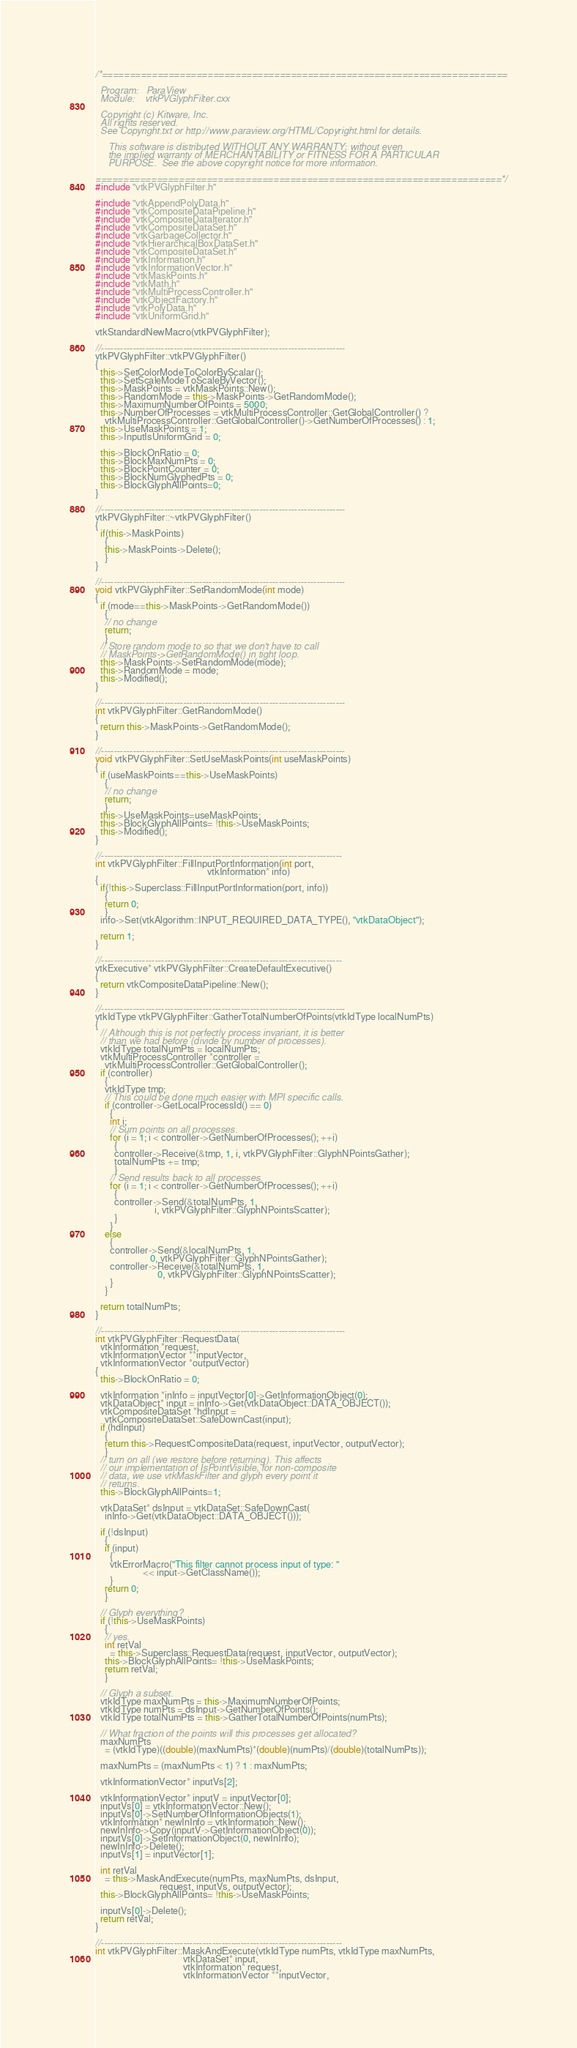Convert code to text. <code><loc_0><loc_0><loc_500><loc_500><_C++_>/*=========================================================================

  Program:   ParaView
  Module:    vtkPVGlyphFilter.cxx

  Copyright (c) Kitware, Inc.
  All rights reserved.
  See Copyright.txt or http://www.paraview.org/HTML/Copyright.html for details.

     This software is distributed WITHOUT ANY WARRANTY; without even
     the implied warranty of MERCHANTABILITY or FITNESS FOR A PARTICULAR
     PURPOSE.  See the above copyright notice for more information.

=========================================================================*/
#include "vtkPVGlyphFilter.h"

#include "vtkAppendPolyData.h"
#include "vtkCompositeDataPipeline.h"
#include "vtkCompositeDataIterator.h"
#include "vtkCompositeDataSet.h"
#include "vtkGarbageCollector.h"
#include "vtkHierarchicalBoxDataSet.h"
#include "vtkCompositeDataSet.h"
#include "vtkInformation.h"
#include "vtkInformationVector.h"
#include "vtkMaskPoints.h"
#include "vtkMath.h"
#include "vtkMultiProcessController.h"
#include "vtkObjectFactory.h"
#include "vtkPolyData.h"
#include "vtkUniformGrid.h"

vtkStandardNewMacro(vtkPVGlyphFilter);

//-----------------------------------------------------------------------------
vtkPVGlyphFilter::vtkPVGlyphFilter()
{
  this->SetColorModeToColorByScalar();
  this->SetScaleModeToScaleByVector();
  this->MaskPoints = vtkMaskPoints::New();
  this->RandomMode = this->MaskPoints->GetRandomMode();
  this->MaximumNumberOfPoints = 5000;
  this->NumberOfProcesses = vtkMultiProcessController::GetGlobalController() ?
    vtkMultiProcessController::GetGlobalController()->GetNumberOfProcesses() : 1;
  this->UseMaskPoints = 1;
  this->InputIsUniformGrid = 0;

  this->BlockOnRatio = 0;
  this->BlockMaxNumPts = 0;
  this->BlockPointCounter = 0;
  this->BlockNumGlyphedPts = 0;
  this->BlockGlyphAllPoints=0;
}

//-----------------------------------------------------------------------------
vtkPVGlyphFilter::~vtkPVGlyphFilter()
{
  if(this->MaskPoints)
    {
    this->MaskPoints->Delete();
    }
}

//-----------------------------------------------------------------------------
void vtkPVGlyphFilter::SetRandomMode(int mode)
{
  if (mode==this->MaskPoints->GetRandomMode())
    {
    // no change
    return;
    }
  // Store random mode to so that we don't have to call
  // MaskPoints->GetRandomMode() in tight loop.
  this->MaskPoints->SetRandomMode(mode);
  this->RandomMode = mode;
  this->Modified();
}

//-----------------------------------------------------------------------------
int vtkPVGlyphFilter::GetRandomMode()
{
  return this->MaskPoints->GetRandomMode();
}

//-----------------------------------------------------------------------------
void vtkPVGlyphFilter::SetUseMaskPoints(int useMaskPoints)
{
  if (useMaskPoints==this->UseMaskPoints)
    {
    // no change
    return;
    }
  this->UseMaskPoints=useMaskPoints;
  this->BlockGlyphAllPoints= !this->UseMaskPoints;
  this->Modified();
}

//----------------------------------------------------------------------------
int vtkPVGlyphFilter::FillInputPortInformation(int port,
                                               vtkInformation* info)
{
  if(!this->Superclass::FillInputPortInformation(port, info))
    {
    return 0;
    }
  info->Set(vtkAlgorithm::INPUT_REQUIRED_DATA_TYPE(), "vtkDataObject");

  return 1;
}

//----------------------------------------------------------------------------
vtkExecutive* vtkPVGlyphFilter::CreateDefaultExecutive()
{
  return vtkCompositeDataPipeline::New();
}

//-----------------------------------------------------------------------------
vtkIdType vtkPVGlyphFilter::GatherTotalNumberOfPoints(vtkIdType localNumPts)
{
  // Although this is not perfectly process invariant, it is better
  // than we had before (divide by number of processes).
  vtkIdType totalNumPts = localNumPts;
  vtkMultiProcessController *controller = 
    vtkMultiProcessController::GetGlobalController();
  if (controller)
    {
    vtkIdType tmp;
    // This could be done much easier with MPI specific calls.
    if (controller->GetLocalProcessId() == 0)
      {
      int i;
      // Sum points on all processes.
      for (i = 1; i < controller->GetNumberOfProcesses(); ++i)
        {
        controller->Receive(&tmp, 1, i, vtkPVGlyphFilter::GlyphNPointsGather);
        totalNumPts += tmp;
        }
      // Send results back to all processes.
      for (i = 1; i < controller->GetNumberOfProcesses(); ++i)
        {
        controller->Send(&totalNumPts, 1, 
                         i, vtkPVGlyphFilter::GlyphNPointsScatter);
        }
      }
    else
      {
      controller->Send(&localNumPts, 1, 
                       0, vtkPVGlyphFilter::GlyphNPointsGather);
      controller->Receive(&totalNumPts, 1, 
                          0, vtkPVGlyphFilter::GlyphNPointsScatter);
      }
    }

  return totalNumPts;
}

//-----------------------------------------------------------------------------
int vtkPVGlyphFilter::RequestData(
  vtkInformation *request,
  vtkInformationVector **inputVector,
  vtkInformationVector *outputVector)
{
  this->BlockOnRatio = 0;

  vtkInformation *inInfo = inputVector[0]->GetInformationObject(0);
  vtkDataObject* input = inInfo->Get(vtkDataObject::DATA_OBJECT());
  vtkCompositeDataSet *hdInput = 
    vtkCompositeDataSet::SafeDownCast(input);
  if (hdInput) 
    {
    return this->RequestCompositeData(request, inputVector, outputVector);
    }
  // turn on all (we restore before returning). This affects
  // our implementation of IsPointVisible, for non-composite
  // data, we use vtkMaskFilter and glyph every point it 
  // returns.
  this->BlockGlyphAllPoints=1;

  vtkDataSet* dsInput = vtkDataSet::SafeDownCast(
    inInfo->Get(vtkDataObject::DATA_OBJECT()));

  if (!dsInput)
    {
    if (input)
      {
      vtkErrorMacro("This filter cannot process input of type: "
                    << input->GetClassName());
      }
    return 0;
    }

  // Glyph everything? 
  if (!this->UseMaskPoints)
    {
    // yes.
    int retVal
      = this->Superclass::RequestData(request, inputVector, outputVector);
    this->BlockGlyphAllPoints= !this->UseMaskPoints;
    return retVal;
    }

  // Glyph a subset.
  vtkIdType maxNumPts = this->MaximumNumberOfPoints;
  vtkIdType numPts = dsInput->GetNumberOfPoints();
  vtkIdType totalNumPts = this->GatherTotalNumberOfPoints(numPts);

  // What fraction of the points will this processes get allocated?
  maxNumPts
    = (vtkIdType)((double)(maxNumPts)*(double)(numPts)/(double)(totalNumPts));

  maxNumPts = (maxNumPts < 1) ? 1 : maxNumPts;

  vtkInformationVector* inputVs[2];

  vtkInformationVector* inputV = inputVector[0];
  inputVs[0] = vtkInformationVector::New();
  inputVs[0]->SetNumberOfInformationObjects(1);
  vtkInformation* newInInfo = vtkInformation::New();
  newInInfo->Copy(inputV->GetInformationObject(0));
  inputVs[0]->SetInformationObject(0, newInInfo);
  newInInfo->Delete();
  inputVs[1] = inputVector[1];

  int retVal
    = this->MaskAndExecute(numPts, maxNumPts, dsInput,
                           request, inputVs, outputVector);
  this->BlockGlyphAllPoints= !this->UseMaskPoints;

  inputVs[0]->Delete();
  return retVal;
}

//----------------------------------------------------------------------------
int vtkPVGlyphFilter::MaskAndExecute(vtkIdType numPts, vtkIdType maxNumPts,
                                     vtkDataSet* input,
                                     vtkInformation* request,
                                     vtkInformationVector **inputVector,</code> 